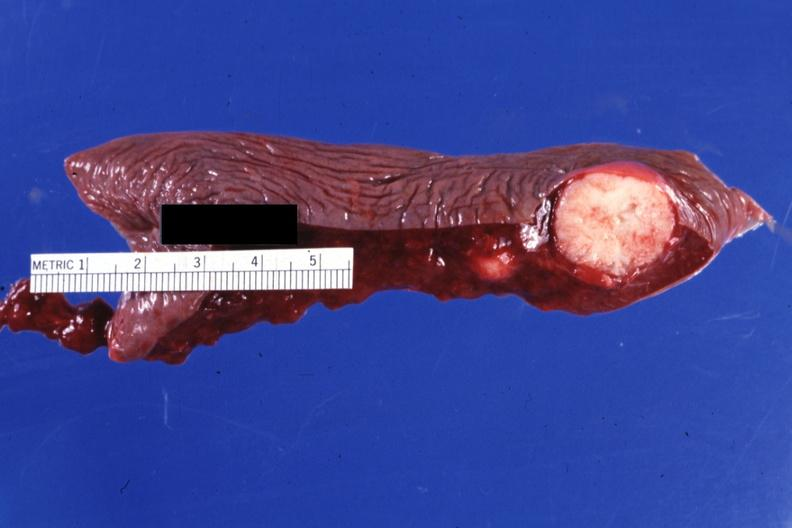s dysplastic present?
Answer the question using a single word or phrase. No 